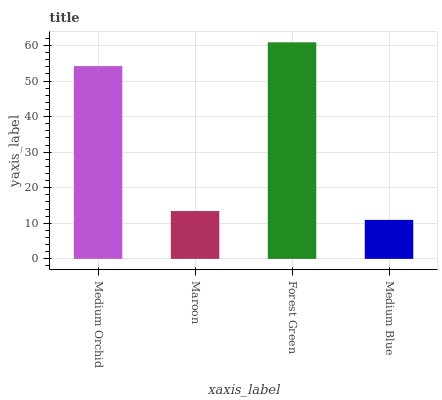Is Maroon the minimum?
Answer yes or no. No. Is Maroon the maximum?
Answer yes or no. No. Is Medium Orchid greater than Maroon?
Answer yes or no. Yes. Is Maroon less than Medium Orchid?
Answer yes or no. Yes. Is Maroon greater than Medium Orchid?
Answer yes or no. No. Is Medium Orchid less than Maroon?
Answer yes or no. No. Is Medium Orchid the high median?
Answer yes or no. Yes. Is Maroon the low median?
Answer yes or no. Yes. Is Medium Blue the high median?
Answer yes or no. No. Is Medium Orchid the low median?
Answer yes or no. No. 